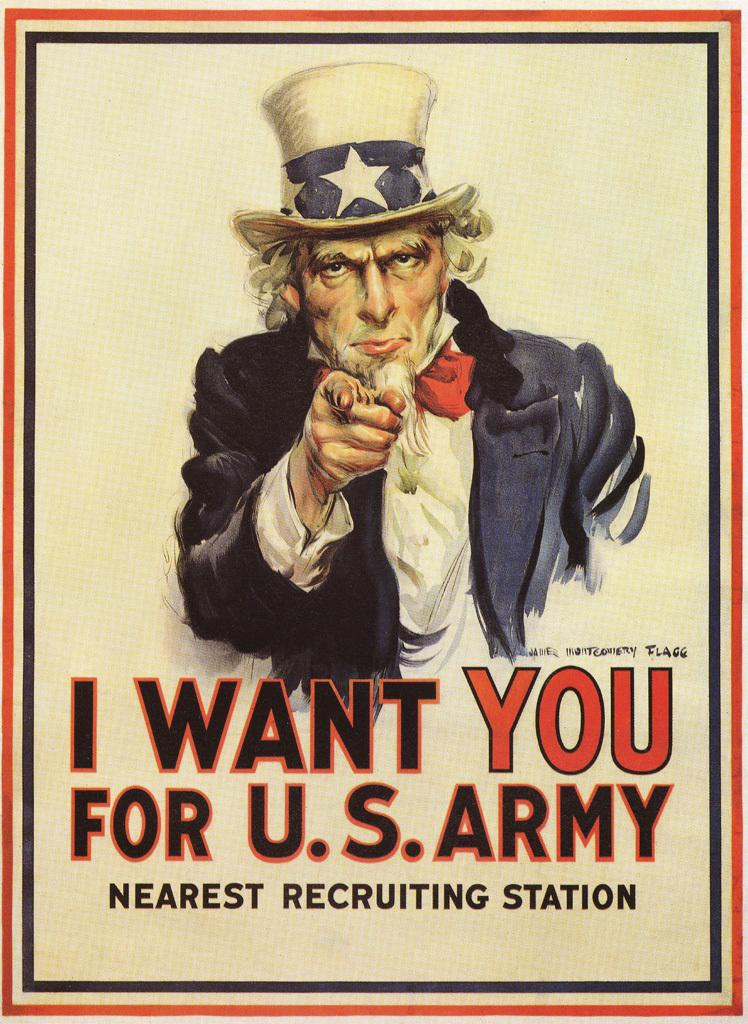<image>
Share a concise interpretation of the image provided. A recruitment poster for the US army with 'I want you' written on it 